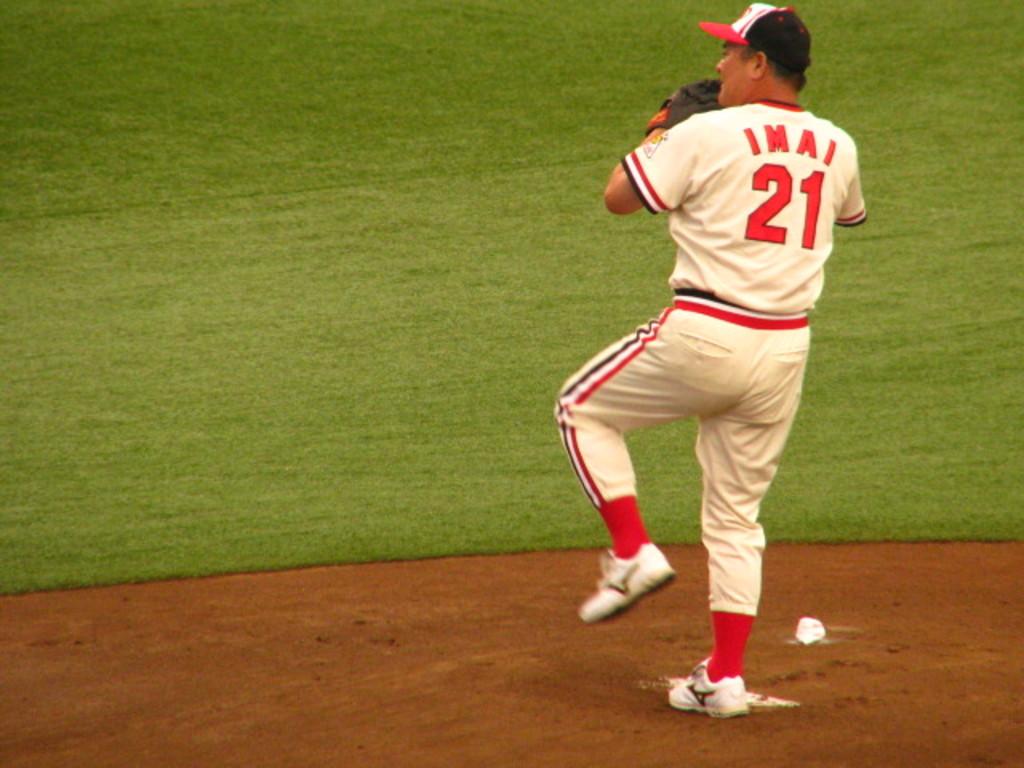What is the players number?
Provide a succinct answer. 21. 